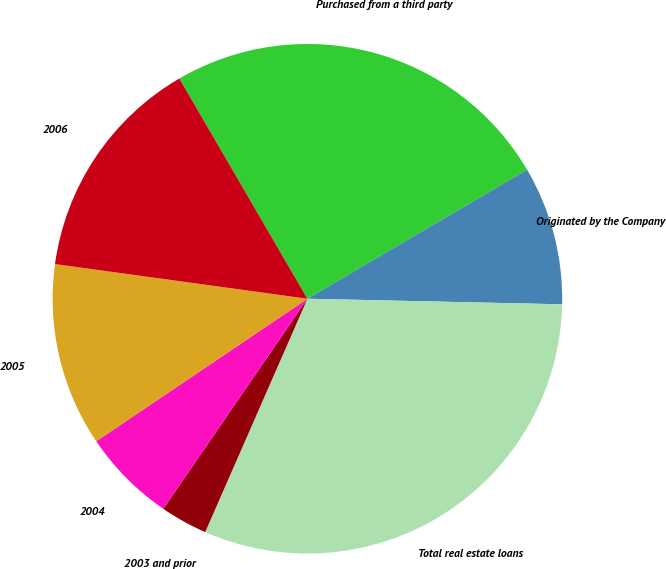Convert chart to OTSL. <chart><loc_0><loc_0><loc_500><loc_500><pie_chart><fcel>Purchased from a third party<fcel>Originated by the Company<fcel>Total real estate loans<fcel>2003 and prior<fcel>2004<fcel>2005<fcel>2006<nl><fcel>24.93%<fcel>8.8%<fcel>31.22%<fcel>3.0%<fcel>5.98%<fcel>11.62%<fcel>14.44%<nl></chart> 